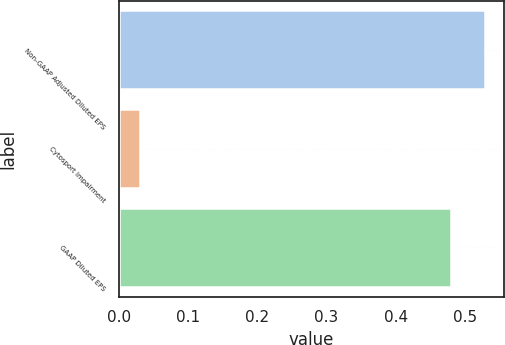Convert chart. <chart><loc_0><loc_0><loc_500><loc_500><bar_chart><fcel>Non-GAAP Adjusted Diluted EPS<fcel>Cytosport Impairment<fcel>GAAP Diluted EPS<nl><fcel>0.53<fcel>0.03<fcel>0.48<nl></chart> 